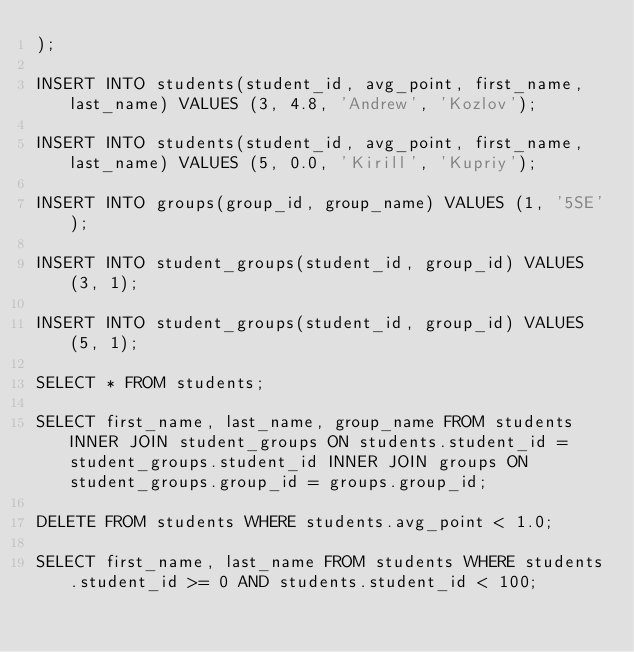<code> <loc_0><loc_0><loc_500><loc_500><_SQL_>);

INSERT INTO students(student_id, avg_point, first_name, last_name) VALUES (3, 4.8, 'Andrew', 'Kozlov');

INSERT INTO students(student_id, avg_point, first_name, last_name) VALUES (5, 0.0, 'Kirill', 'Kupriy');

INSERT INTO groups(group_id, group_name) VALUES (1, '5SE');

INSERT INTO student_groups(student_id, group_id) VALUES (3, 1);

INSERT INTO student_groups(student_id, group_id) VALUES (5, 1);

SELECT * FROM students;

SELECT first_name, last_name, group_name FROM students INNER JOIN student_groups ON students.student_id = student_groups.student_id INNER JOIN groups ON student_groups.group_id = groups.group_id;

DELETE FROM students WHERE students.avg_point < 1.0;

SELECT first_name, last_name FROM students WHERE students.student_id >= 0 AND students.student_id < 100;
</code> 